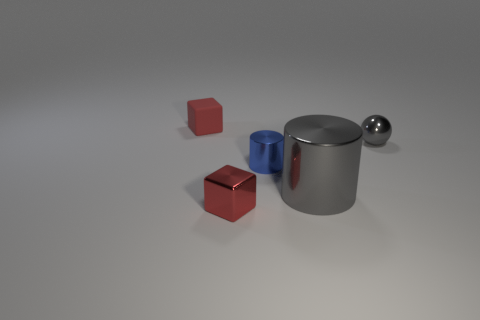What is the size of the block to the left of the red block that is in front of the shiny object to the right of the gray shiny cylinder?
Provide a succinct answer. Small. How many cylinders are the same size as the red shiny block?
Give a very brief answer. 1. What number of things are small red metal cylinders or cylinders that are in front of the tiny blue metal cylinder?
Your response must be concise. 1. There is a small gray shiny thing; what shape is it?
Offer a terse response. Sphere. Is the big thing the same color as the small metallic sphere?
Provide a succinct answer. Yes. What is the color of the metallic sphere that is the same size as the blue metallic object?
Keep it short and to the point. Gray. How many green objects are large things or tiny rubber things?
Your answer should be compact. 0. Are there more large metallic things than small red things?
Your answer should be compact. No. There is a red block that is on the left side of the tiny red metal object; is it the same size as the metal object left of the tiny cylinder?
Give a very brief answer. Yes. The block that is in front of the thing that is right of the metallic cylinder that is in front of the small cylinder is what color?
Your response must be concise. Red. 